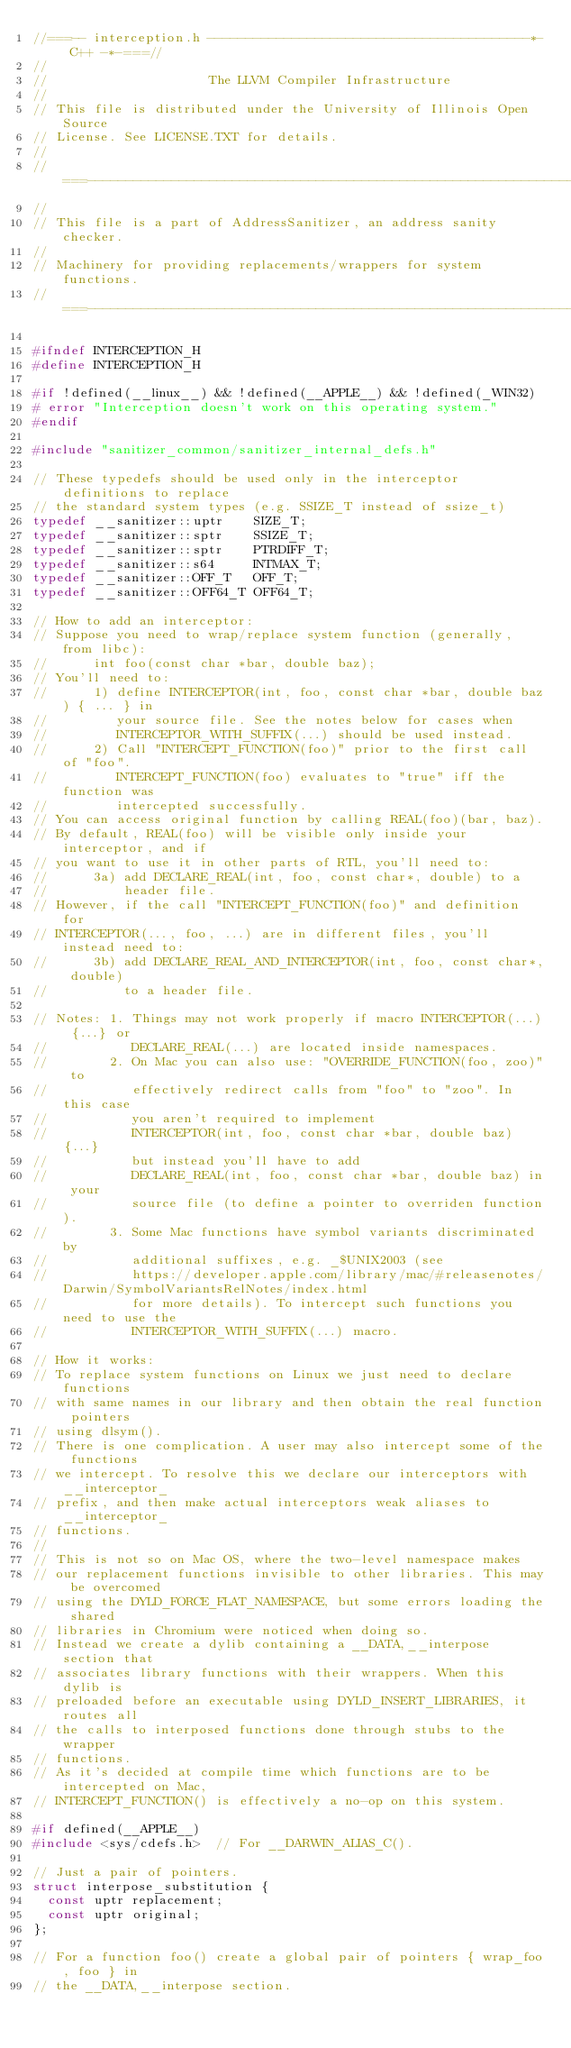<code> <loc_0><loc_0><loc_500><loc_500><_C_>//===-- interception.h ------------------------------------------*- C++ -*-===//
//
//                     The LLVM Compiler Infrastructure
//
// This file is distributed under the University of Illinois Open Source
// License. See LICENSE.TXT for details.
//
//===----------------------------------------------------------------------===//
//
// This file is a part of AddressSanitizer, an address sanity checker.
//
// Machinery for providing replacements/wrappers for system functions.
//===----------------------------------------------------------------------===//

#ifndef INTERCEPTION_H
#define INTERCEPTION_H

#if !defined(__linux__) && !defined(__APPLE__) && !defined(_WIN32)
# error "Interception doesn't work on this operating system."
#endif

#include "sanitizer_common/sanitizer_internal_defs.h"

// These typedefs should be used only in the interceptor definitions to replace
// the standard system types (e.g. SSIZE_T instead of ssize_t)
typedef __sanitizer::uptr    SIZE_T;
typedef __sanitizer::sptr    SSIZE_T;
typedef __sanitizer::sptr    PTRDIFF_T;
typedef __sanitizer::s64     INTMAX_T;
typedef __sanitizer::OFF_T   OFF_T;
typedef __sanitizer::OFF64_T OFF64_T;

// How to add an interceptor:
// Suppose you need to wrap/replace system function (generally, from libc):
//      int foo(const char *bar, double baz);
// You'll need to:
//      1) define INTERCEPTOR(int, foo, const char *bar, double baz) { ... } in
//         your source file. See the notes below for cases when
//         INTERCEPTOR_WITH_SUFFIX(...) should be used instead.
//      2) Call "INTERCEPT_FUNCTION(foo)" prior to the first call of "foo".
//         INTERCEPT_FUNCTION(foo) evaluates to "true" iff the function was
//         intercepted successfully.
// You can access original function by calling REAL(foo)(bar, baz).
// By default, REAL(foo) will be visible only inside your interceptor, and if
// you want to use it in other parts of RTL, you'll need to:
//      3a) add DECLARE_REAL(int, foo, const char*, double) to a
//          header file.
// However, if the call "INTERCEPT_FUNCTION(foo)" and definition for
// INTERCEPTOR(..., foo, ...) are in different files, you'll instead need to:
//      3b) add DECLARE_REAL_AND_INTERCEPTOR(int, foo, const char*, double)
//          to a header file.

// Notes: 1. Things may not work properly if macro INTERCEPTOR(...) {...} or
//           DECLARE_REAL(...) are located inside namespaces.
//        2. On Mac you can also use: "OVERRIDE_FUNCTION(foo, zoo)" to
//           effectively redirect calls from "foo" to "zoo". In this case
//           you aren't required to implement
//           INTERCEPTOR(int, foo, const char *bar, double baz) {...}
//           but instead you'll have to add
//           DECLARE_REAL(int, foo, const char *bar, double baz) in your
//           source file (to define a pointer to overriden function).
//        3. Some Mac functions have symbol variants discriminated by
//           additional suffixes, e.g. _$UNIX2003 (see
//           https://developer.apple.com/library/mac/#releasenotes/Darwin/SymbolVariantsRelNotes/index.html
//           for more details). To intercept such functions you need to use the
//           INTERCEPTOR_WITH_SUFFIX(...) macro.

// How it works:
// To replace system functions on Linux we just need to declare functions
// with same names in our library and then obtain the real function pointers
// using dlsym().
// There is one complication. A user may also intercept some of the functions
// we intercept. To resolve this we declare our interceptors with __interceptor_
// prefix, and then make actual interceptors weak aliases to __interceptor_
// functions.
//
// This is not so on Mac OS, where the two-level namespace makes
// our replacement functions invisible to other libraries. This may be overcomed
// using the DYLD_FORCE_FLAT_NAMESPACE, but some errors loading the shared
// libraries in Chromium were noticed when doing so.
// Instead we create a dylib containing a __DATA,__interpose section that
// associates library functions with their wrappers. When this dylib is
// preloaded before an executable using DYLD_INSERT_LIBRARIES, it routes all
// the calls to interposed functions done through stubs to the wrapper
// functions.
// As it's decided at compile time which functions are to be intercepted on Mac,
// INTERCEPT_FUNCTION() is effectively a no-op on this system.

#if defined(__APPLE__)
#include <sys/cdefs.h>  // For __DARWIN_ALIAS_C().

// Just a pair of pointers.
struct interpose_substitution {
  const uptr replacement;
  const uptr original;
};

// For a function foo() create a global pair of pointers { wrap_foo, foo } in
// the __DATA,__interpose section.</code> 